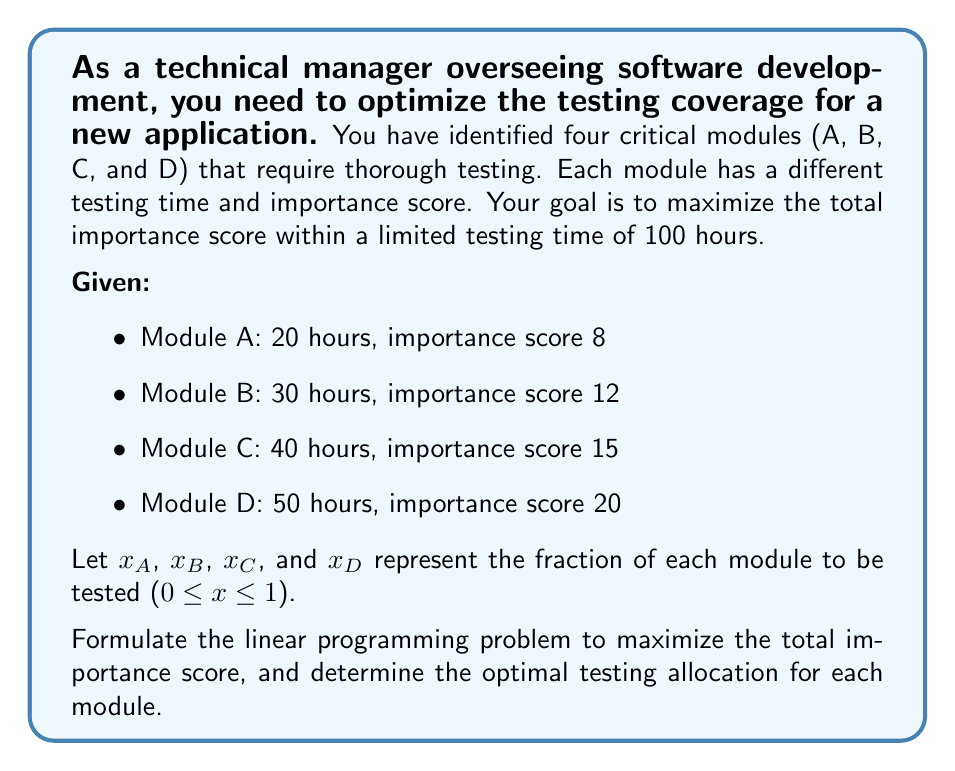Show me your answer to this math problem. To solve this problem, we need to set up a linear programming model:

1. Define the objective function:
   Maximize: $Z = 8x_A + 12x_B + 15x_C + 20x_D$

2. Define the constraints:
   Time constraint: $20x_A + 30x_B + 40x_C + 50x_D \leq 100$
   Fraction constraints: $0 \leq x_A, x_B, x_C, x_D \leq 1$

3. Solve using the simplex method or linear programming software:

   The optimal solution is:
   $x_A = 1$ (test 100% of module A)
   $x_B = 1$ (test 100% of module B)
   $x_C = 1$ (test 100% of module C)
   $x_D = 0.2$ (test 20% of module D)

4. Calculate the total importance score:
   $Z = 8(1) + 12(1) + 15(1) + 20(0.2) = 39$

5. Verify the time constraint:
   $20(1) + 30(1) + 40(1) + 50(0.2) = 100$ hours

This solution maximizes the importance score while staying within the 100-hour time limit.
Answer: The optimal testing allocation is:
Module A: 100%
Module B: 100%
Module C: 100%
Module D: 20%

The maximum total importance score achieved is 39. 